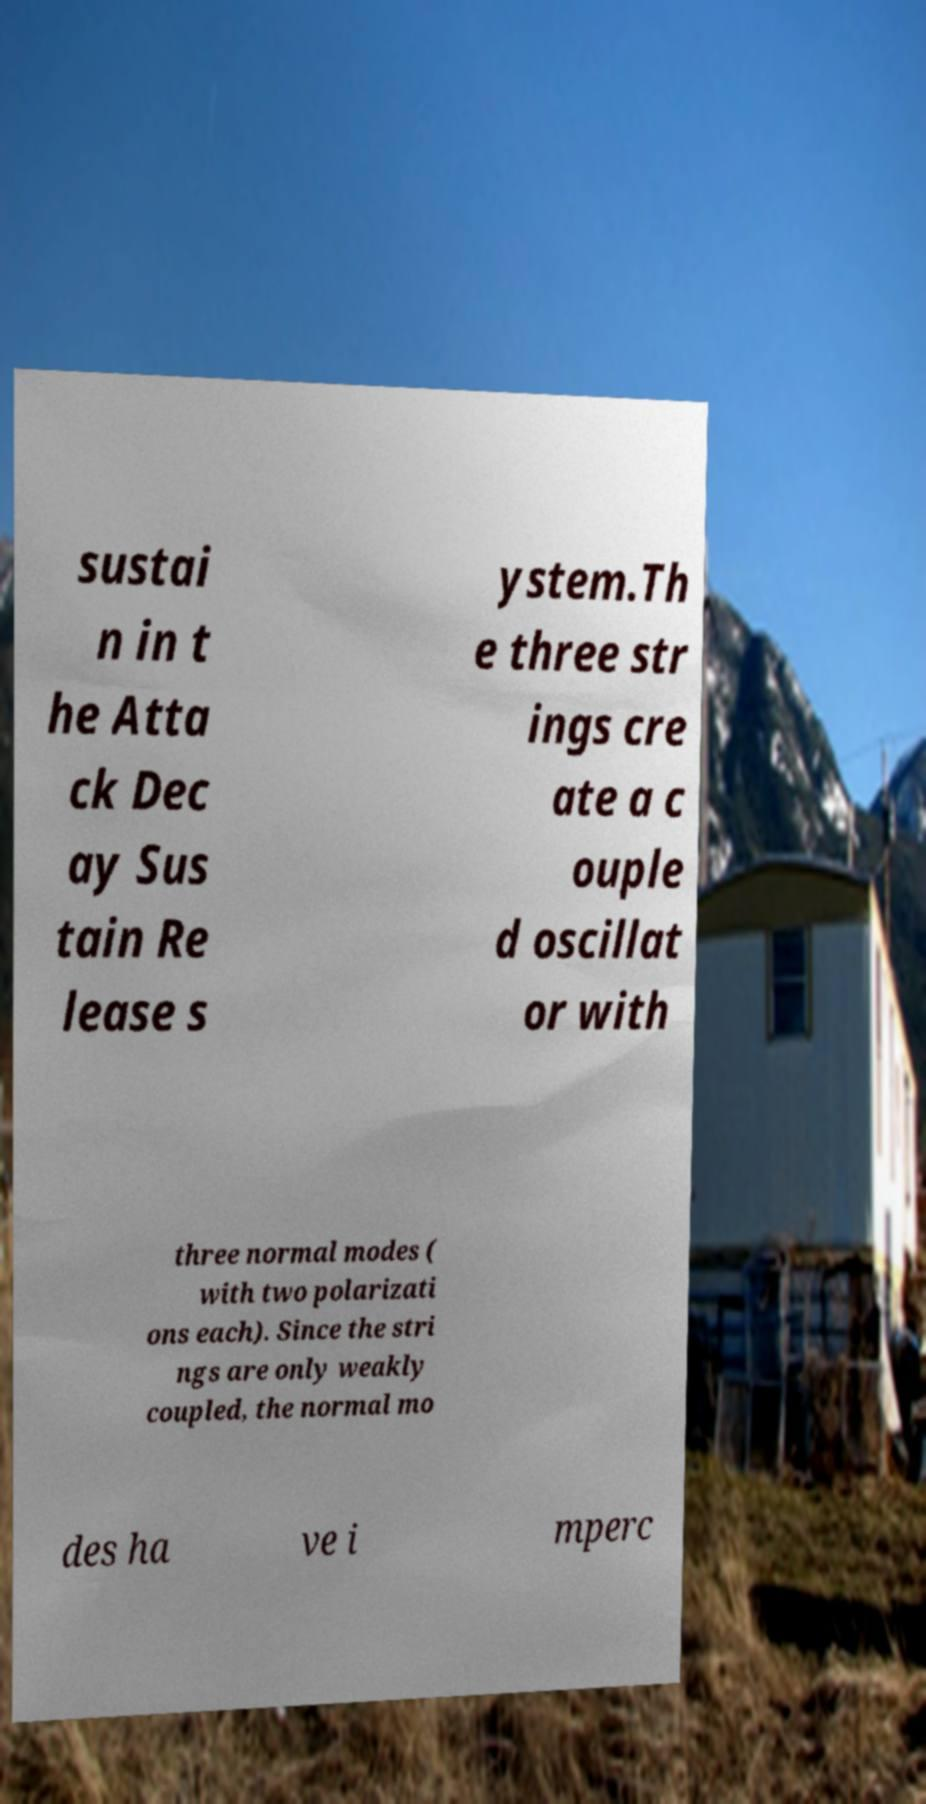Could you extract and type out the text from this image? sustai n in t he Atta ck Dec ay Sus tain Re lease s ystem.Th e three str ings cre ate a c ouple d oscillat or with three normal modes ( with two polarizati ons each). Since the stri ngs are only weakly coupled, the normal mo des ha ve i mperc 